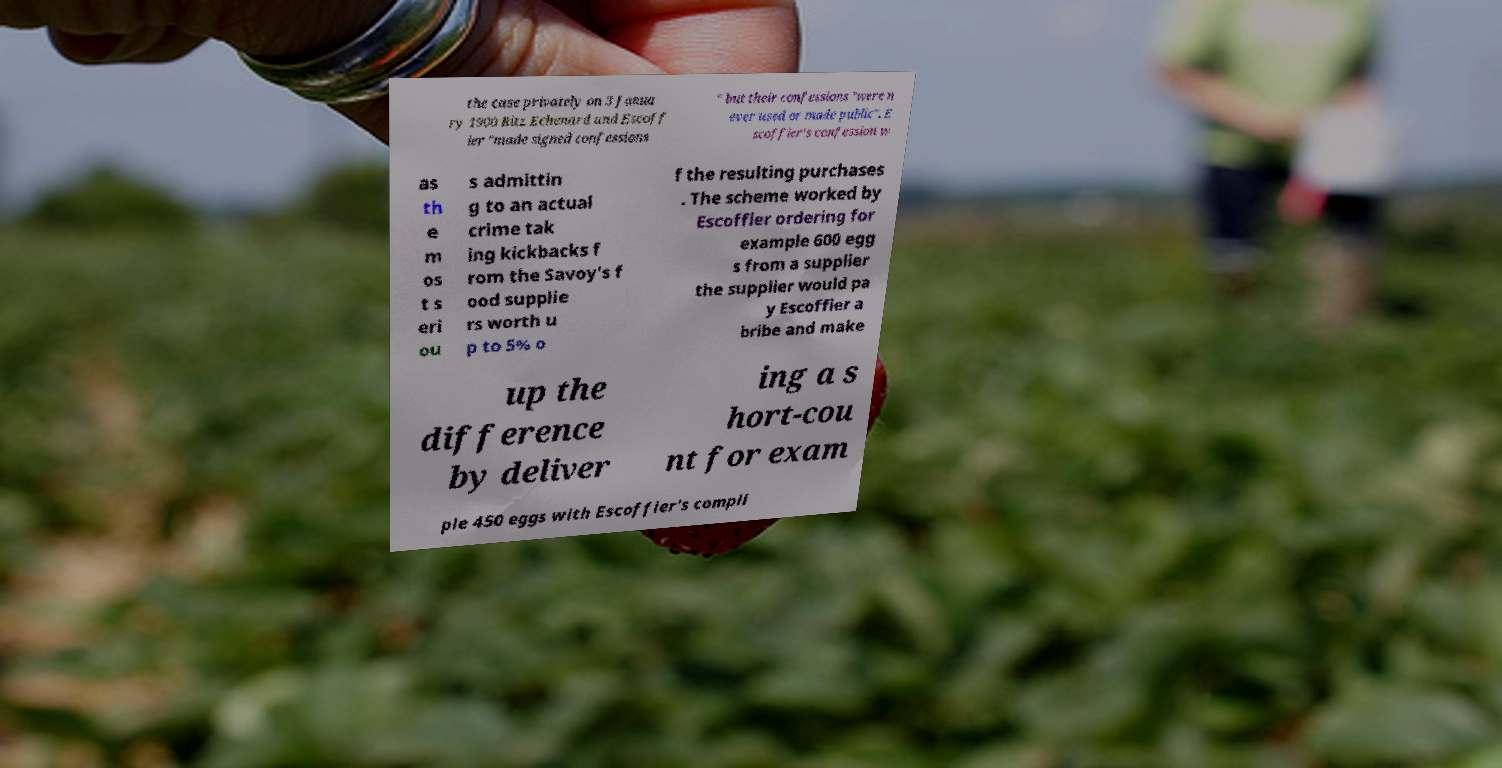I need the written content from this picture converted into text. Can you do that? the case privately on 3 Janua ry 1900 Ritz Echenard and Escoff ier "made signed confessions " but their confessions "were n ever used or made public". E scoffier's confession w as th e m os t s eri ou s admittin g to an actual crime tak ing kickbacks f rom the Savoy's f ood supplie rs worth u p to 5% o f the resulting purchases . The scheme worked by Escoffier ordering for example 600 egg s from a supplier the supplier would pa y Escoffier a bribe and make up the difference by deliver ing a s hort-cou nt for exam ple 450 eggs with Escoffier's compli 